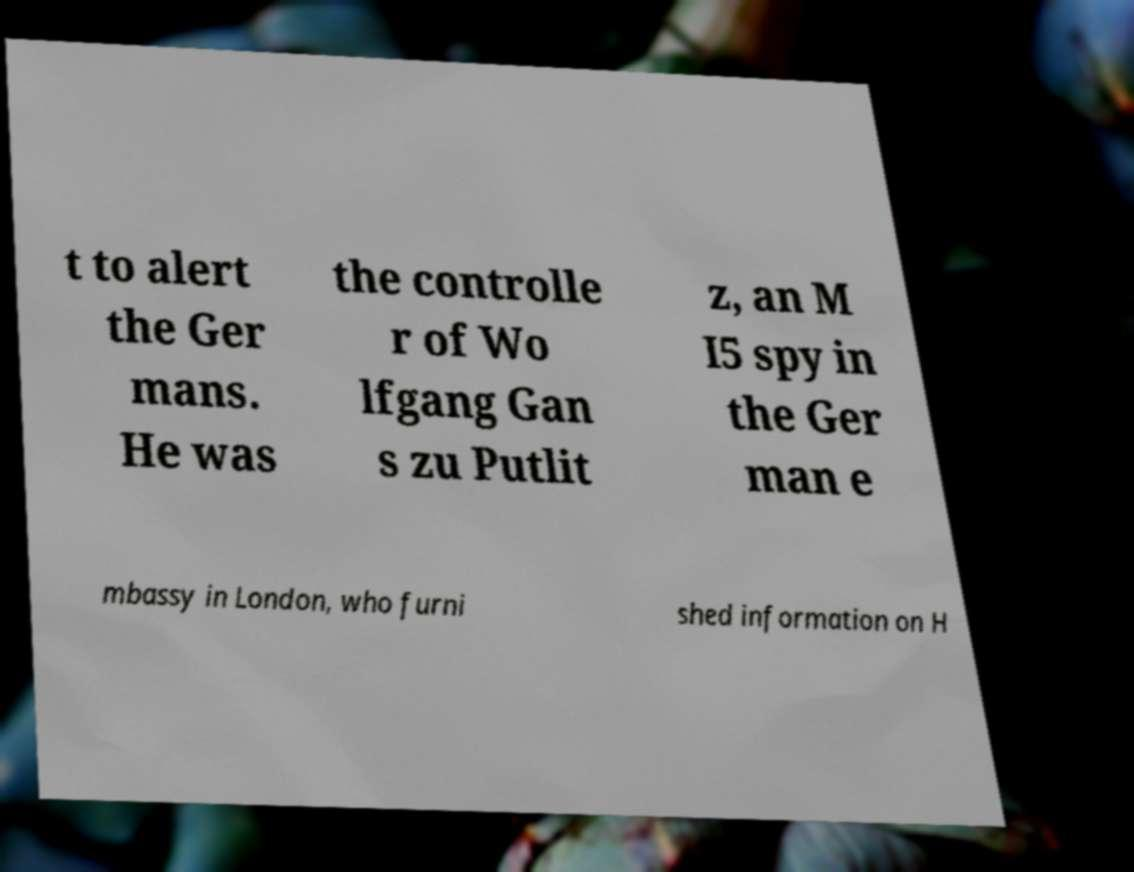I need the written content from this picture converted into text. Can you do that? t to alert the Ger mans. He was the controlle r of Wo lfgang Gan s zu Putlit z, an M I5 spy in the Ger man e mbassy in London, who furni shed information on H 